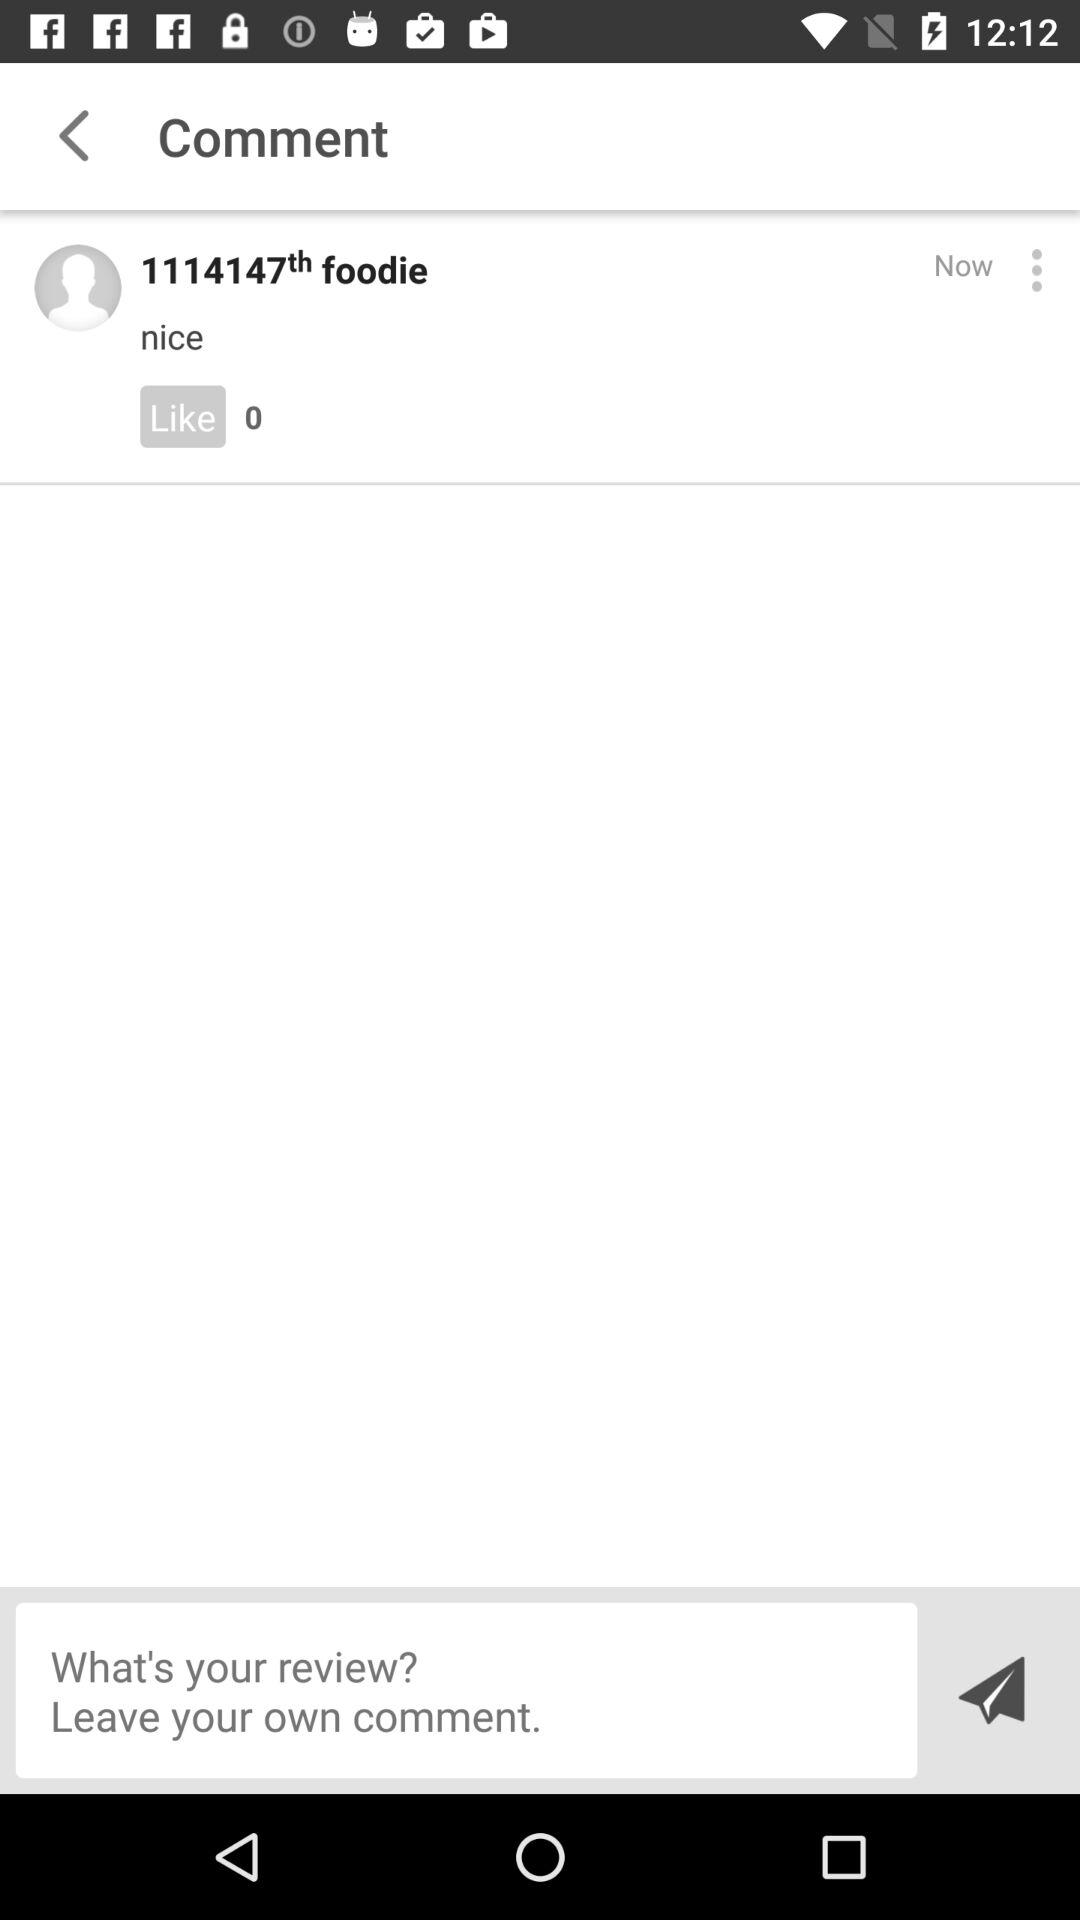How many people have viewed the comment?
When the provided information is insufficient, respond with <no answer>. <no answer> 